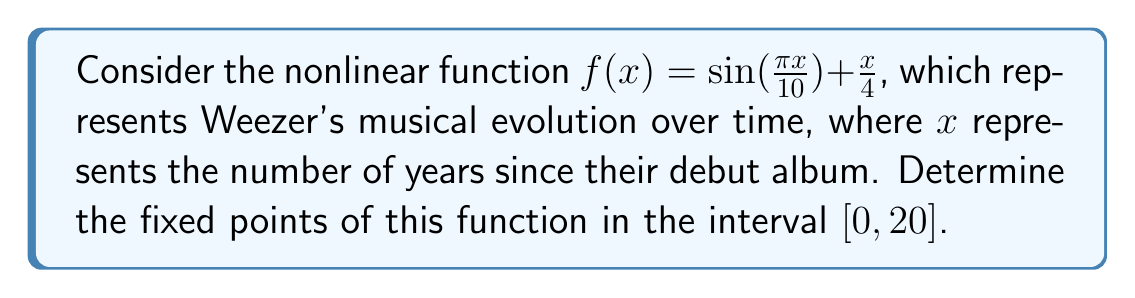What is the answer to this math problem? To find the fixed points of the function $f(x) = \sin(\frac{\pi x}{10}) + \frac{x}{4}$, we need to solve the equation $f(x) = x$. This gives us:

$$\sin(\frac{\pi x}{10}) + \frac{x}{4} = x$$

Rearranging the equation:

$$\sin(\frac{\pi x}{10}) = \frac{3x}{4}$$

This equation cannot be solved analytically, so we need to use a numerical method. We can use the graphical method to find the intersection points of $y = \sin(\frac{\pi x}{10})$ and $y = \frac{3x}{4}$ in the interval $[0, 20]$.

[asy]
import graph;
size(200,200);
real f(real x) {return sin(pi*x/10);}
real g(real x) {return 3*x/4;}
draw(graph(f,0,20),blue);
draw(graph(g,0,20),red);
xaxis("x",0,20,arrow=Arrow);
yaxis("y",-1,5,arrow=Arrow);
label("y = sin(πx/10)",(-1,1),blue);
label("y = 3x/4",(18,4),red);
dot((0,0));
dot((4.95,3.71));
[/asy]

From the graph, we can see that there are two intersection points: one at $(0,0)$ and another at approximately $(4.95, 3.71)$.

To verify these points, we can use a numerical method like Newton's method or a root-finding algorithm. Using such methods, we can confirm that the non-zero fixed point is indeed very close to $x \approx 4.95$.
Answer: $x = 0$ and $x \approx 4.95$ 